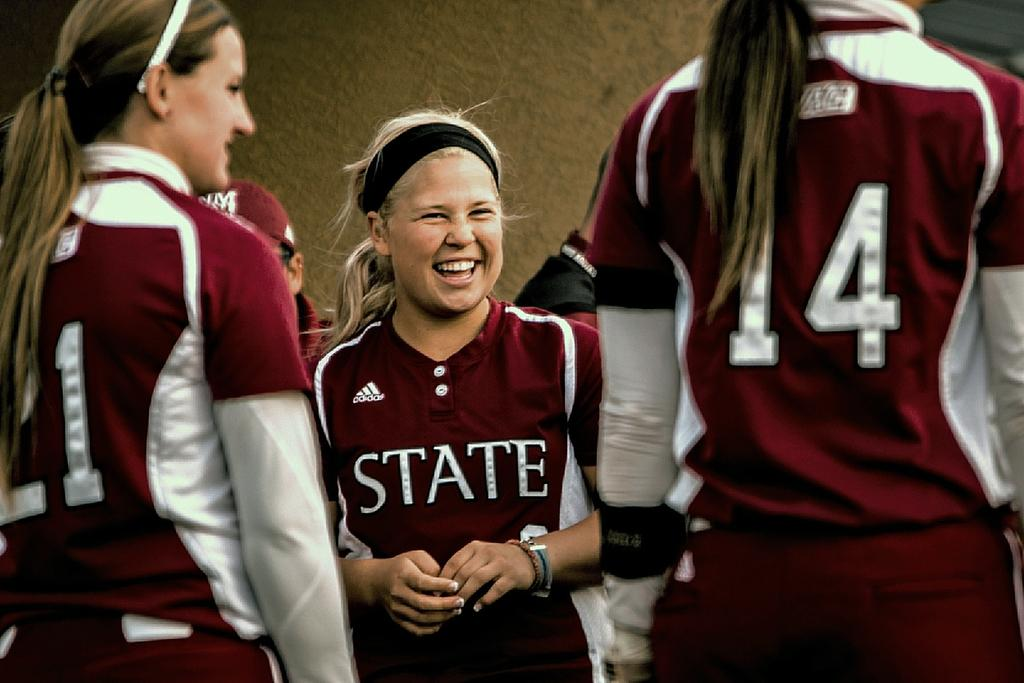<image>
Present a compact description of the photo's key features. A girl is wearing a jersey with the word state on it. 